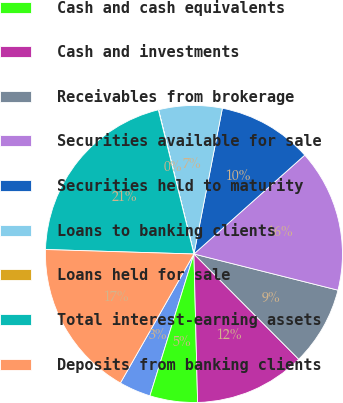Convert chart to OTSL. <chart><loc_0><loc_0><loc_500><loc_500><pie_chart><fcel>Year Ended December 31<fcel>Cash and cash equivalents<fcel>Cash and investments<fcel>Receivables from brokerage<fcel>Securities available for sale<fcel>Securities held to maturity<fcel>Loans to banking clients<fcel>Loans held for sale<fcel>Total interest-earning assets<fcel>Deposits from banking clients<nl><fcel>3.46%<fcel>5.18%<fcel>12.07%<fcel>8.62%<fcel>15.51%<fcel>10.34%<fcel>6.9%<fcel>0.02%<fcel>20.67%<fcel>17.23%<nl></chart> 